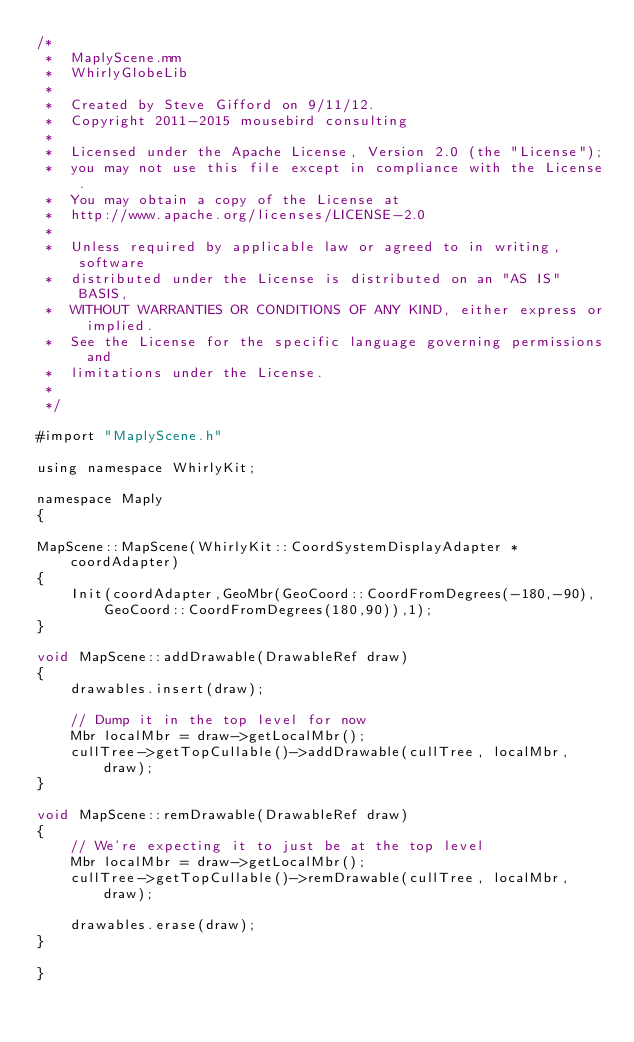Convert code to text. <code><loc_0><loc_0><loc_500><loc_500><_ObjectiveC_>/*
 *  MaplyScene.mm
 *  WhirlyGlobeLib
 *
 *  Created by Steve Gifford on 9/11/12.
 *  Copyright 2011-2015 mousebird consulting
 *
 *  Licensed under the Apache License, Version 2.0 (the "License");
 *  you may not use this file except in compliance with the License.
 *  You may obtain a copy of the License at
 *  http://www.apache.org/licenses/LICENSE-2.0
 *
 *  Unless required by applicable law or agreed to in writing, software
 *  distributed under the License is distributed on an "AS IS" BASIS,
 *  WITHOUT WARRANTIES OR CONDITIONS OF ANY KIND, either express or implied.
 *  See the License for the specific language governing permissions and
 *  limitations under the License.
 *
 */

#import "MaplyScene.h"

using namespace WhirlyKit;

namespace Maply
{
    
MapScene::MapScene(WhirlyKit::CoordSystemDisplayAdapter *coordAdapter)
{
    Init(coordAdapter,GeoMbr(GeoCoord::CoordFromDegrees(-180,-90),GeoCoord::CoordFromDegrees(180,90)),1);
}
    
void MapScene::addDrawable(DrawableRef draw)
{
    drawables.insert(draw);
    
    // Dump it in the top level for now
    Mbr localMbr = draw->getLocalMbr();
    cullTree->getTopCullable()->addDrawable(cullTree, localMbr, draw);
}

void MapScene::remDrawable(DrawableRef draw)
{
    // We're expecting it to just be at the top level
    Mbr localMbr = draw->getLocalMbr();
    cullTree->getTopCullable()->remDrawable(cullTree, localMbr, draw);
    
    drawables.erase(draw);
}
    
}
</code> 